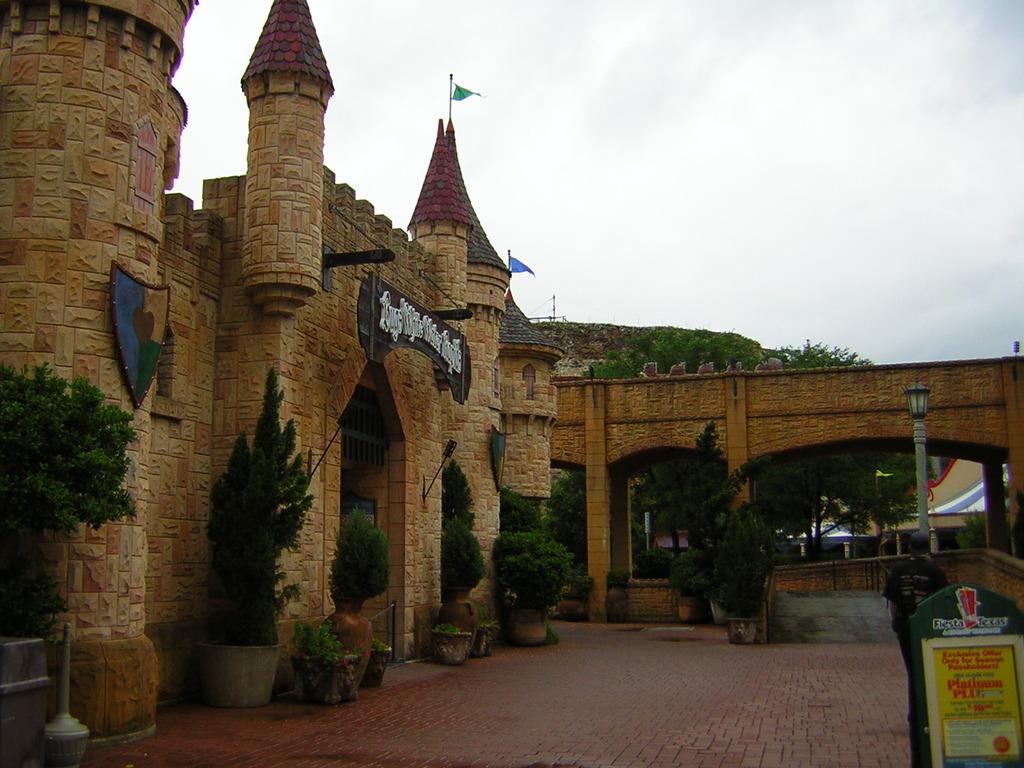In one or two sentences, can you explain what this image depicts? In this picture we can see name boards, shield, house plants, pillars, light pole, building, flags, trees and some objects a person and in the background we can see the sky with clouds. 